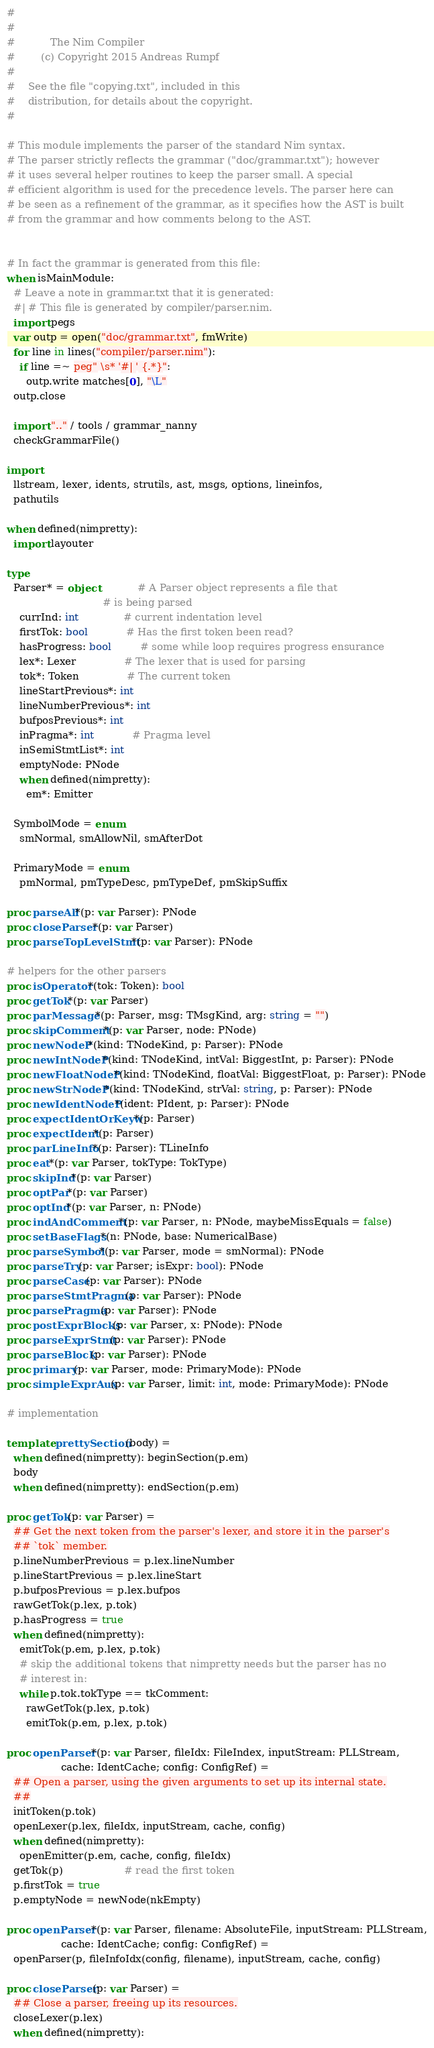<code> <loc_0><loc_0><loc_500><loc_500><_Nim_>#
#
#           The Nim Compiler
#        (c) Copyright 2015 Andreas Rumpf
#
#    See the file "copying.txt", included in this
#    distribution, for details about the copyright.
#

# This module implements the parser of the standard Nim syntax.
# The parser strictly reflects the grammar ("doc/grammar.txt"); however
# it uses several helper routines to keep the parser small. A special
# efficient algorithm is used for the precedence levels. The parser here can
# be seen as a refinement of the grammar, as it specifies how the AST is built
# from the grammar and how comments belong to the AST.


# In fact the grammar is generated from this file:
when isMainModule:
  # Leave a note in grammar.txt that it is generated:
  #| # This file is generated by compiler/parser.nim.
  import pegs
  var outp = open("doc/grammar.txt", fmWrite)
  for line in lines("compiler/parser.nim"):
    if line =~ peg" \s* '#| ' {.*}":
      outp.write matches[0], "\L"
  outp.close

  import ".." / tools / grammar_nanny
  checkGrammarFile()

import
  llstream, lexer, idents, strutils, ast, msgs, options, lineinfos,
  pathutils

when defined(nimpretty):
  import layouter

type
  Parser* = object            # A Parser object represents a file that
                              # is being parsed
    currInd: int              # current indentation level
    firstTok: bool            # Has the first token been read?
    hasProgress: bool         # some while loop requires progress ensurance
    lex*: Lexer               # The lexer that is used for parsing
    tok*: Token               # The current token
    lineStartPrevious*: int
    lineNumberPrevious*: int
    bufposPrevious*: int
    inPragma*: int            # Pragma level
    inSemiStmtList*: int
    emptyNode: PNode
    when defined(nimpretty):
      em*: Emitter

  SymbolMode = enum
    smNormal, smAllowNil, smAfterDot

  PrimaryMode = enum
    pmNormal, pmTypeDesc, pmTypeDef, pmSkipSuffix

proc parseAll*(p: var Parser): PNode
proc closeParser*(p: var Parser)
proc parseTopLevelStmt*(p: var Parser): PNode

# helpers for the other parsers
proc isOperator*(tok: Token): bool
proc getTok*(p: var Parser)
proc parMessage*(p: Parser, msg: TMsgKind, arg: string = "")
proc skipComment*(p: var Parser, node: PNode)
proc newNodeP*(kind: TNodeKind, p: Parser): PNode
proc newIntNodeP*(kind: TNodeKind, intVal: BiggestInt, p: Parser): PNode
proc newFloatNodeP*(kind: TNodeKind, floatVal: BiggestFloat, p: Parser): PNode
proc newStrNodeP*(kind: TNodeKind, strVal: string, p: Parser): PNode
proc newIdentNodeP*(ident: PIdent, p: Parser): PNode
proc expectIdentOrKeyw*(p: Parser)
proc expectIdent*(p: Parser)
proc parLineInfo*(p: Parser): TLineInfo
proc eat*(p: var Parser, tokType: TokType)
proc skipInd*(p: var Parser)
proc optPar*(p: var Parser)
proc optInd*(p: var Parser, n: PNode)
proc indAndComment*(p: var Parser, n: PNode, maybeMissEquals = false)
proc setBaseFlags*(n: PNode, base: NumericalBase)
proc parseSymbol*(p: var Parser, mode = smNormal): PNode
proc parseTry(p: var Parser; isExpr: bool): PNode
proc parseCase(p: var Parser): PNode
proc parseStmtPragma(p: var Parser): PNode
proc parsePragma(p: var Parser): PNode
proc postExprBlocks(p: var Parser, x: PNode): PNode
proc parseExprStmt(p: var Parser): PNode
proc parseBlock(p: var Parser): PNode
proc primary(p: var Parser, mode: PrimaryMode): PNode
proc simpleExprAux(p: var Parser, limit: int, mode: PrimaryMode): PNode

# implementation

template prettySection(body) =
  when defined(nimpretty): beginSection(p.em)
  body
  when defined(nimpretty): endSection(p.em)

proc getTok(p: var Parser) =
  ## Get the next token from the parser's lexer, and store it in the parser's
  ## `tok` member.
  p.lineNumberPrevious = p.lex.lineNumber
  p.lineStartPrevious = p.lex.lineStart
  p.bufposPrevious = p.lex.bufpos
  rawGetTok(p.lex, p.tok)
  p.hasProgress = true
  when defined(nimpretty):
    emitTok(p.em, p.lex, p.tok)
    # skip the additional tokens that nimpretty needs but the parser has no
    # interest in:
    while p.tok.tokType == tkComment:
      rawGetTok(p.lex, p.tok)
      emitTok(p.em, p.lex, p.tok)

proc openParser*(p: var Parser, fileIdx: FileIndex, inputStream: PLLStream,
                 cache: IdentCache; config: ConfigRef) =
  ## Open a parser, using the given arguments to set up its internal state.
  ##
  initToken(p.tok)
  openLexer(p.lex, fileIdx, inputStream, cache, config)
  when defined(nimpretty):
    openEmitter(p.em, cache, config, fileIdx)
  getTok(p)                   # read the first token
  p.firstTok = true
  p.emptyNode = newNode(nkEmpty)

proc openParser*(p: var Parser, filename: AbsoluteFile, inputStream: PLLStream,
                 cache: IdentCache; config: ConfigRef) =
  openParser(p, fileInfoIdx(config, filename), inputStream, cache, config)

proc closeParser(p: var Parser) =
  ## Close a parser, freeing up its resources.
  closeLexer(p.lex)
  when defined(nimpretty):</code> 